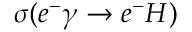Convert formula to latex. <formula><loc_0><loc_0><loc_500><loc_500>\sigma ( e ^ { - } \gamma \rightarrow e ^ { - } H )</formula> 